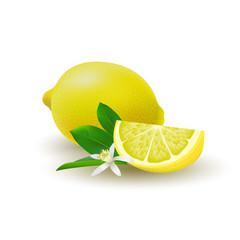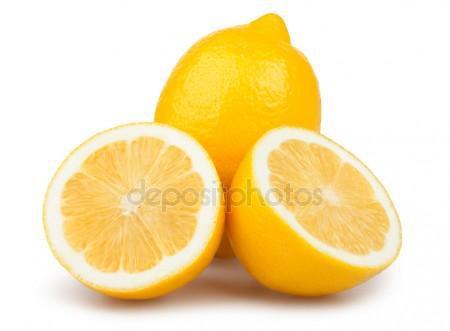The first image is the image on the left, the second image is the image on the right. Examine the images to the left and right. Is the description "The combined images include exactly one cut half lemon and at least eleven whole citrus fruits." accurate? Answer yes or no. No. The first image is the image on the left, the second image is the image on the right. For the images displayed, is the sentence "There is a sliced lemon in exactly one image." factually correct? Answer yes or no. No. 